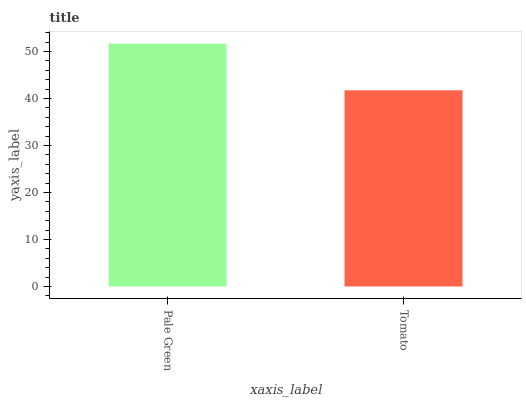Is Tomato the maximum?
Answer yes or no. No. Is Pale Green greater than Tomato?
Answer yes or no. Yes. Is Tomato less than Pale Green?
Answer yes or no. Yes. Is Tomato greater than Pale Green?
Answer yes or no. No. Is Pale Green less than Tomato?
Answer yes or no. No. Is Pale Green the high median?
Answer yes or no. Yes. Is Tomato the low median?
Answer yes or no. Yes. Is Tomato the high median?
Answer yes or no. No. Is Pale Green the low median?
Answer yes or no. No. 